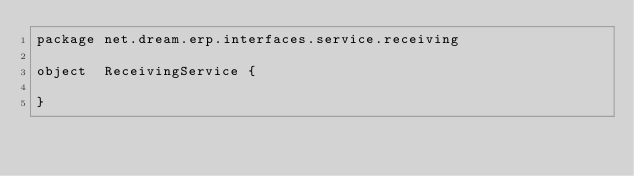<code> <loc_0><loc_0><loc_500><loc_500><_Scala_>package net.dream.erp.interfaces.service.receiving

object  ReceivingService {

}
</code> 